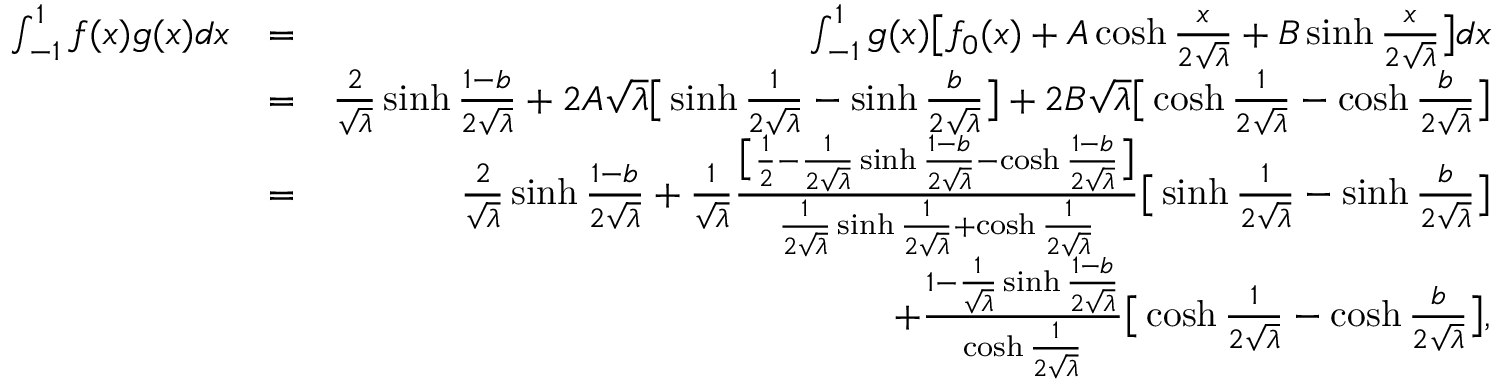<formula> <loc_0><loc_0><loc_500><loc_500>\begin{array} { r l r } { \int _ { - 1 } ^ { 1 } f ( x ) g ( x ) d x } & { = } & { \int _ { - 1 } ^ { 1 } g ( x ) \left [ f _ { 0 } ( x ) + A \cosh \frac { x } { 2 \sqrt { \lambda } } + B \sinh \frac { x } { 2 \sqrt { \lambda } } \right ] d x } \\ & { = } & { \frac { 2 } { \sqrt { \lambda } } \sinh \frac { 1 - b } { 2 \sqrt { \lambda } } + 2 A \sqrt { \lambda } \left [ \sinh \frac { 1 } { 2 \sqrt { \lambda } } - \sinh \frac { b } { 2 \sqrt { \lambda } } \right ] + 2 B \sqrt { \lambda } \left [ \cosh \frac { 1 } { 2 \sqrt { \lambda } } - \cosh \frac { b } { 2 \sqrt { \lambda } } \right ] } \\ & { = } & { \frac { 2 } { \sqrt { \lambda } } \sinh \frac { 1 - b } { 2 \sqrt { \lambda } } + \frac { 1 } { \sqrt { \lambda } } \frac { \left [ \frac { 1 } { 2 } - \frac { 1 } { 2 \sqrt { \lambda } } \sinh \frac { 1 - b } { 2 \sqrt { \lambda } } - \cosh \frac { 1 - b } { 2 \sqrt { \lambda } } \right ] } { \frac { 1 } { 2 \sqrt { \lambda } } \sinh \frac { 1 } { 2 \sqrt { \lambda } } + \cosh \frac { 1 } { 2 \sqrt { \lambda } } } \left [ \sinh \frac { 1 } { 2 \sqrt { \lambda } } - \sinh \frac { b } { 2 \sqrt { \lambda } } \right ] } \\ & { + \frac { 1 - \frac { 1 } { \sqrt { \lambda } } \sinh \frac { 1 - b } { 2 \sqrt { \lambda } } } { \cosh \frac { 1 } { 2 \sqrt { \lambda } } } \left [ \cosh \frac { 1 } { 2 \sqrt { \lambda } } - \cosh \frac { b } { 2 \sqrt { \lambda } } \right ] , } \end{array}</formula> 